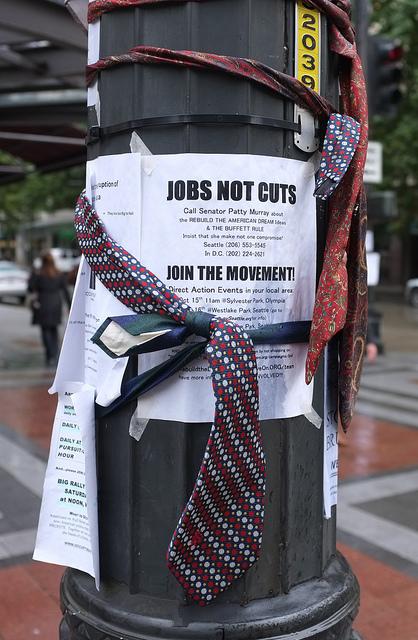What is wrapped around the pole?
Write a very short answer. Ties. What is this poster trying to accomplish?
Give a very brief answer. Protest. What are the numbers on the pole?
Give a very brief answer. 2039. 